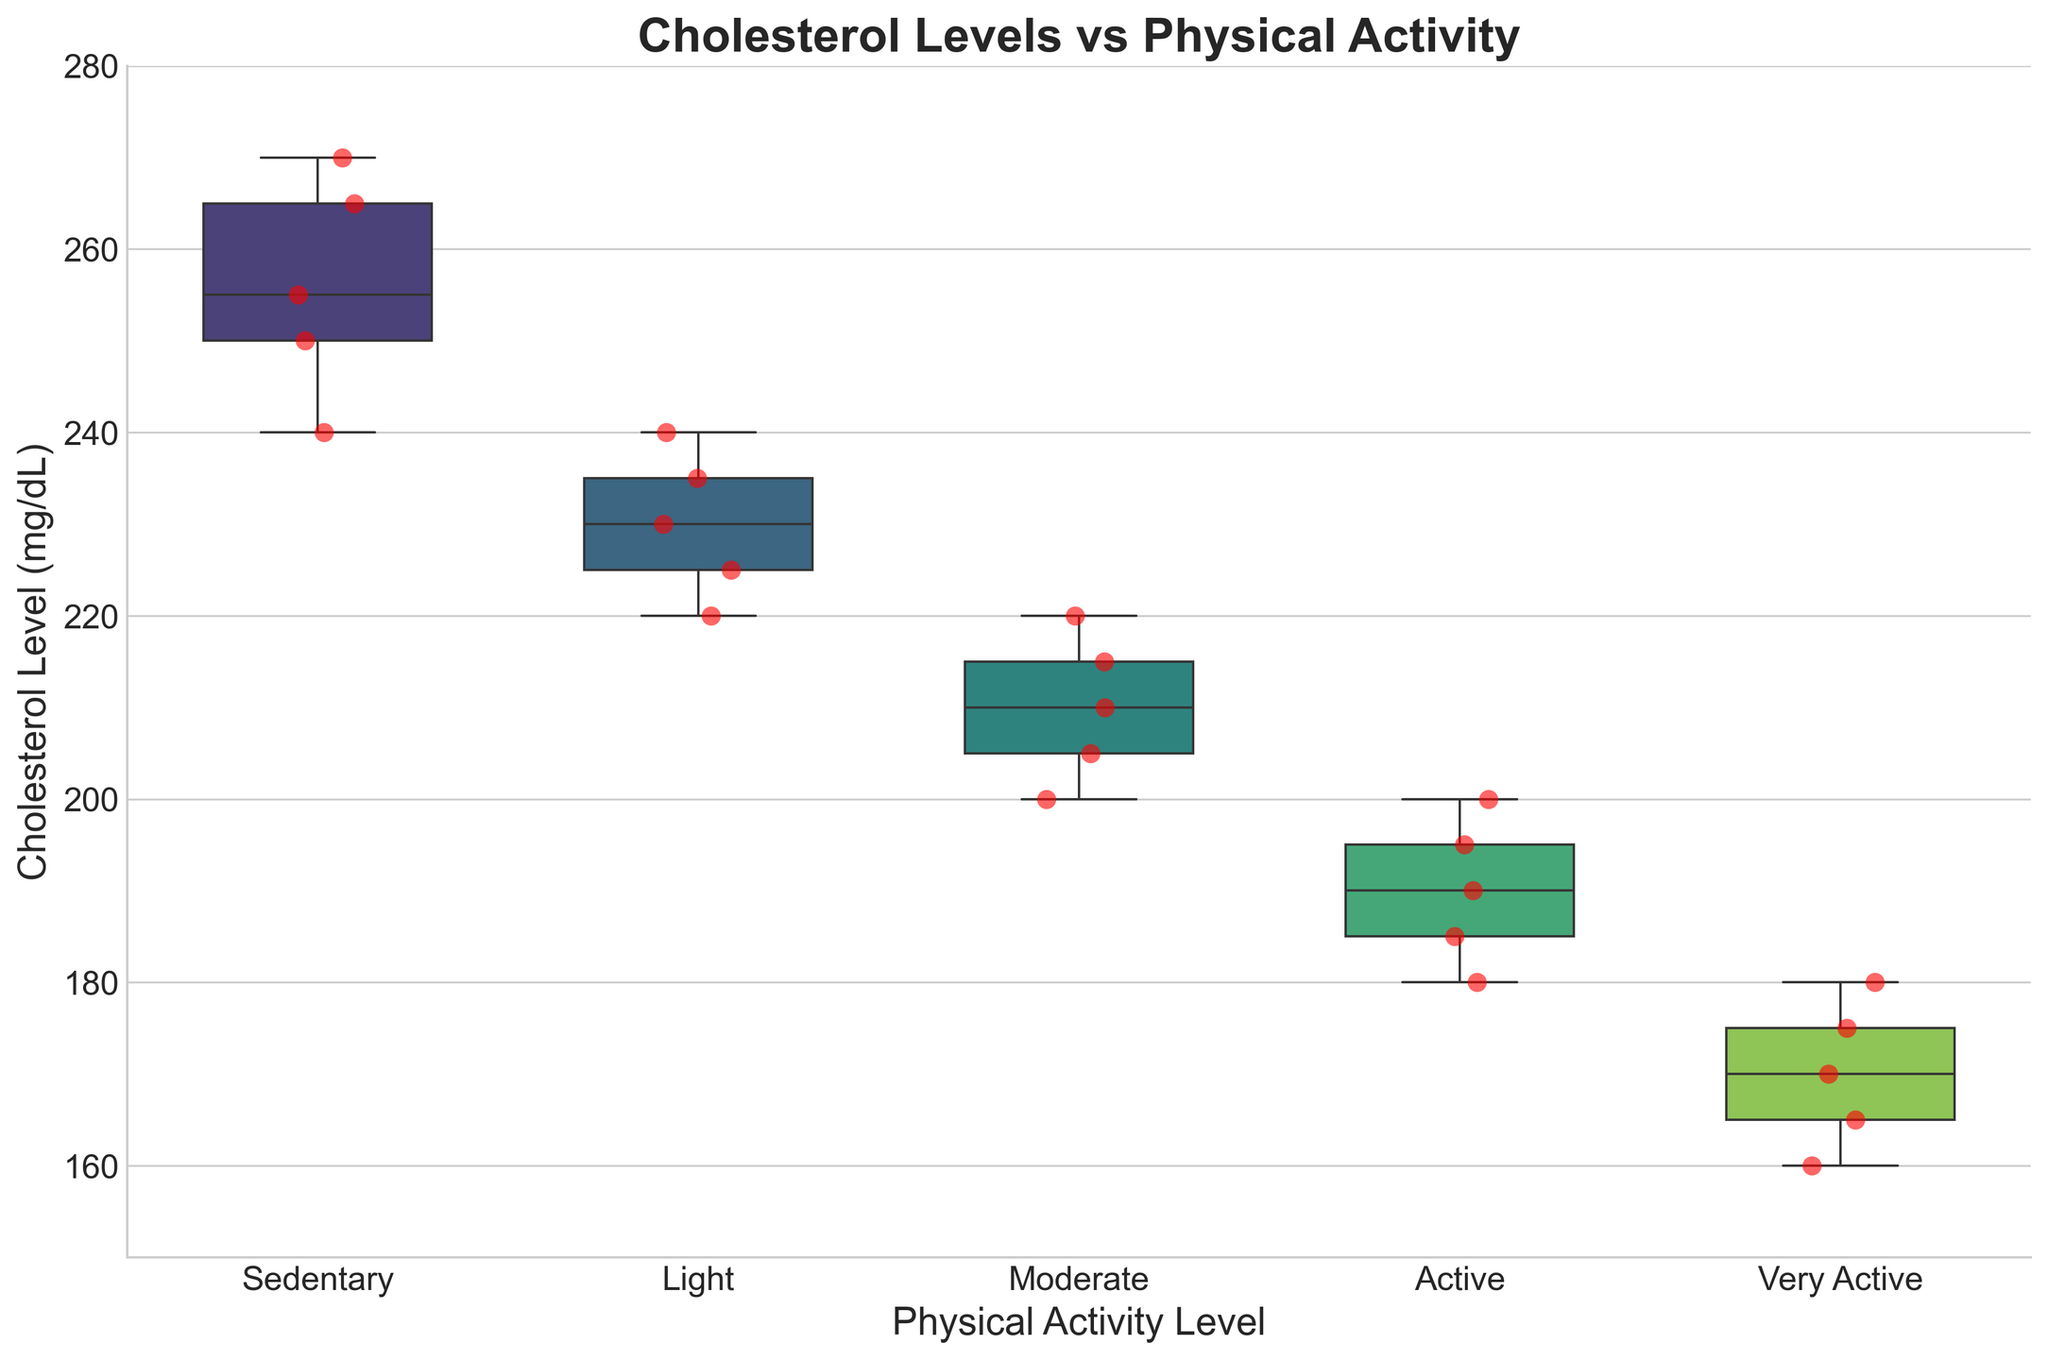What is the title of the plot? The title of the plot is found at the top of the figure and indicates the main subject of the visualization.
Answer: Cholesterol Levels vs Physical Activity What are the Physical Activity Levels listed on the x-axis? The x-axis represents the different categories of physical activity levels. They are labelled at the bottom of the plot.
Answer: Sedentary, Light, Moderate, Active, Very Active Which group has the highest median Cholesterol Level? The median is represented by the horizontal line inside each box. The group with the highest median will have this line positioned higher on the y-axis.
Answer: Sedentary What are the range of Cholesterol Levels in the "Very Active" group? The range is the distance between the top and bottom of the box, which represents the interquartile range (IQR), and the whiskers which show the full range of the data, excluding outliers.
Answer: 160 to 180 How many individual data points are in the "Light" physical activity group? The scatter points within each box plot represent individual data points. Counting these red points in the "Light" group gives the answer.
Answer: 5 What is the difference between the highest cholesterol level in the "Sedentary" group and the lowest in the "Active" group? The highest value in "Sedentary" can be found by looking at the highest point (top whisker) in that category, and the lowest value in "Active" can be found by the lowest point (bottom whisker) in that category. Subtract the lowest "Active" value from the highest "Sedentary" value.
Answer: 270 - 180 = 90 Which group exhibits the lowest variability in cholesterol levels? The variability is represented by the spread of the box and whiskers. The group with the smallest range between the top and bottom whiskers has the lowest variability.
Answer: Very Active How does the interquartile range (IQR) of the "Moderate" group compare to the "Sedentary" group? The IQR is the range covered by the box (from the bottom to the top). Compare the length of these boxes for "Moderate" and "Sedentary."
Answer: Smaller in Moderate What is the approximate median cholesterol level in the "Light" physical activity group? The median is the line inside the box of the "Light" group.
Answer: 230 Which group has cholesterol levels closest to 200 mg/dL? Check for the proximity of scatter points to the 200 mark on the y-axis among all groups.
Answer: Active 